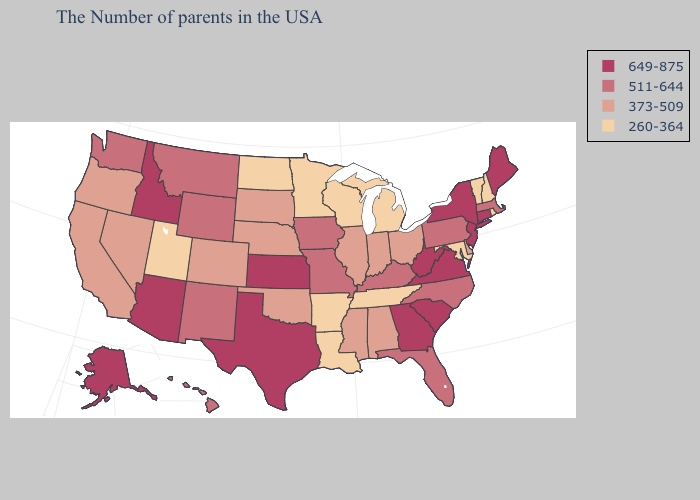Which states have the lowest value in the USA?
Quick response, please. Rhode Island, New Hampshire, Vermont, Maryland, Michigan, Tennessee, Wisconsin, Louisiana, Arkansas, Minnesota, North Dakota, Utah. Among the states that border Iowa , does Minnesota have the lowest value?
Give a very brief answer. Yes. Does Michigan have the highest value in the MidWest?
Write a very short answer. No. What is the lowest value in the Northeast?
Concise answer only. 260-364. Does Pennsylvania have the same value as North Carolina?
Give a very brief answer. Yes. Name the states that have a value in the range 649-875?
Give a very brief answer. Maine, Connecticut, New York, New Jersey, Virginia, South Carolina, West Virginia, Georgia, Kansas, Texas, Arizona, Idaho, Alaska. Does North Dakota have the lowest value in the MidWest?
Answer briefly. Yes. Does South Dakota have the lowest value in the MidWest?
Short answer required. No. Name the states that have a value in the range 511-644?
Keep it brief. Massachusetts, Pennsylvania, North Carolina, Florida, Kentucky, Missouri, Iowa, Wyoming, New Mexico, Montana, Washington, Hawaii. Does Illinois have a lower value than Arizona?
Quick response, please. Yes. Does Tennessee have the lowest value in the USA?
Answer briefly. Yes. Name the states that have a value in the range 511-644?
Keep it brief. Massachusetts, Pennsylvania, North Carolina, Florida, Kentucky, Missouri, Iowa, Wyoming, New Mexico, Montana, Washington, Hawaii. Does Vermont have the highest value in the Northeast?
Concise answer only. No. Which states have the lowest value in the USA?
Be succinct. Rhode Island, New Hampshire, Vermont, Maryland, Michigan, Tennessee, Wisconsin, Louisiana, Arkansas, Minnesota, North Dakota, Utah. Does the map have missing data?
Short answer required. No. 